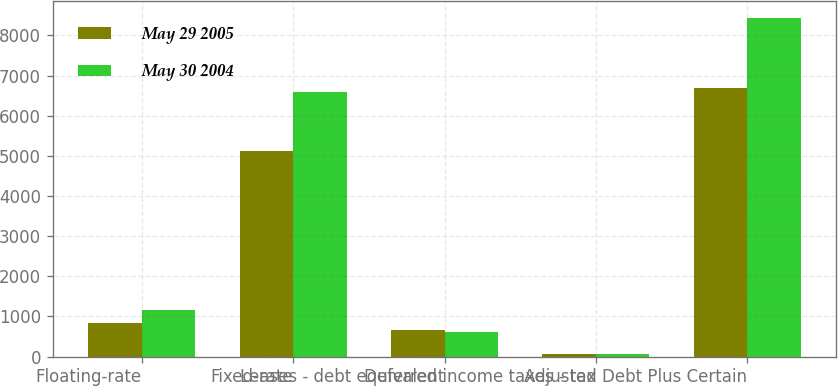<chart> <loc_0><loc_0><loc_500><loc_500><stacked_bar_chart><ecel><fcel>Floating-rate<fcel>Fixed-rate<fcel>Leases - debt equivalent<fcel>Deferred income taxes - tax<fcel>Adjusted Debt Plus Certain<nl><fcel>May 29 2005<fcel>838<fcel>5119<fcel>672<fcel>64<fcel>6693<nl><fcel>May 30 2004<fcel>1169<fcel>6603<fcel>600<fcel>66<fcel>8438<nl></chart> 